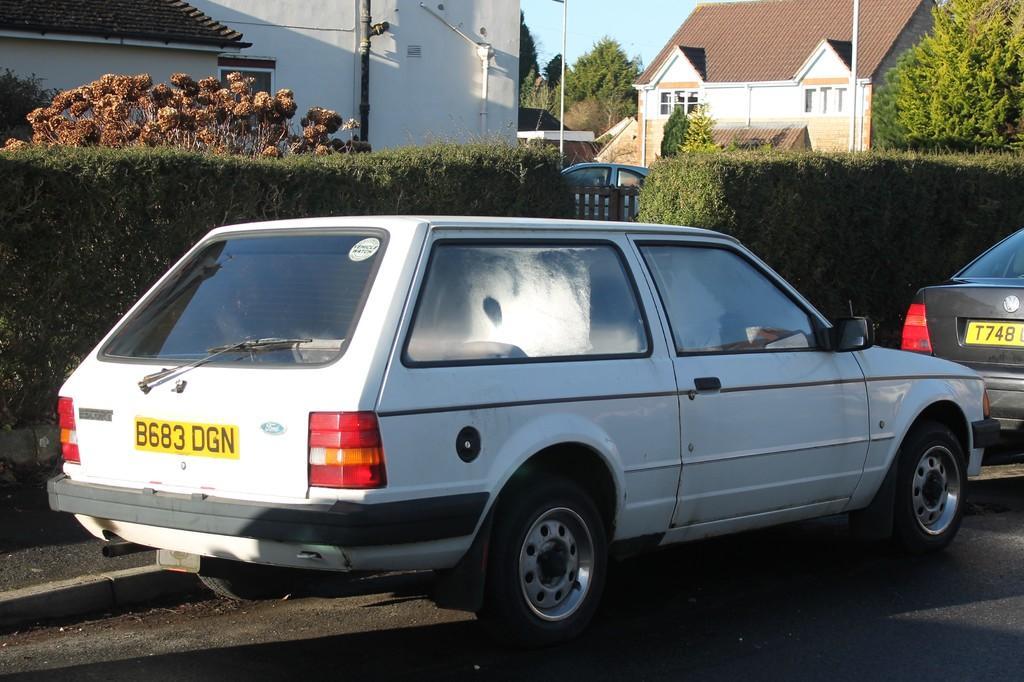How would you summarize this image in a sentence or two? In this image I can see a road in the front and on it I can see two cars. In the background I can see bushes, wooden fencing, plants, few buildings, number of trees, few poles and the sky. I can also see one more car in the background. 